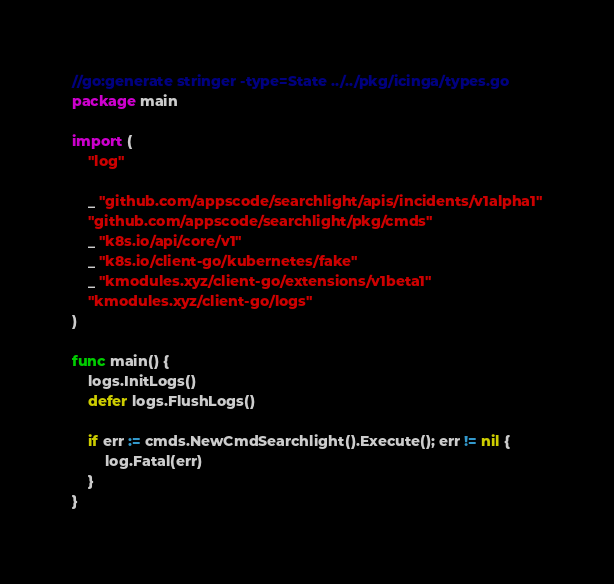Convert code to text. <code><loc_0><loc_0><loc_500><loc_500><_Go_>//go:generate stringer -type=State ../../pkg/icinga/types.go
package main

import (
	"log"

	_ "github.com/appscode/searchlight/apis/incidents/v1alpha1"
	"github.com/appscode/searchlight/pkg/cmds"
	_ "k8s.io/api/core/v1"
	_ "k8s.io/client-go/kubernetes/fake"
	_ "kmodules.xyz/client-go/extensions/v1beta1"
	"kmodules.xyz/client-go/logs"
)

func main() {
	logs.InitLogs()
	defer logs.FlushLogs()

	if err := cmds.NewCmdSearchlight().Execute(); err != nil {
		log.Fatal(err)
	}
}
</code> 